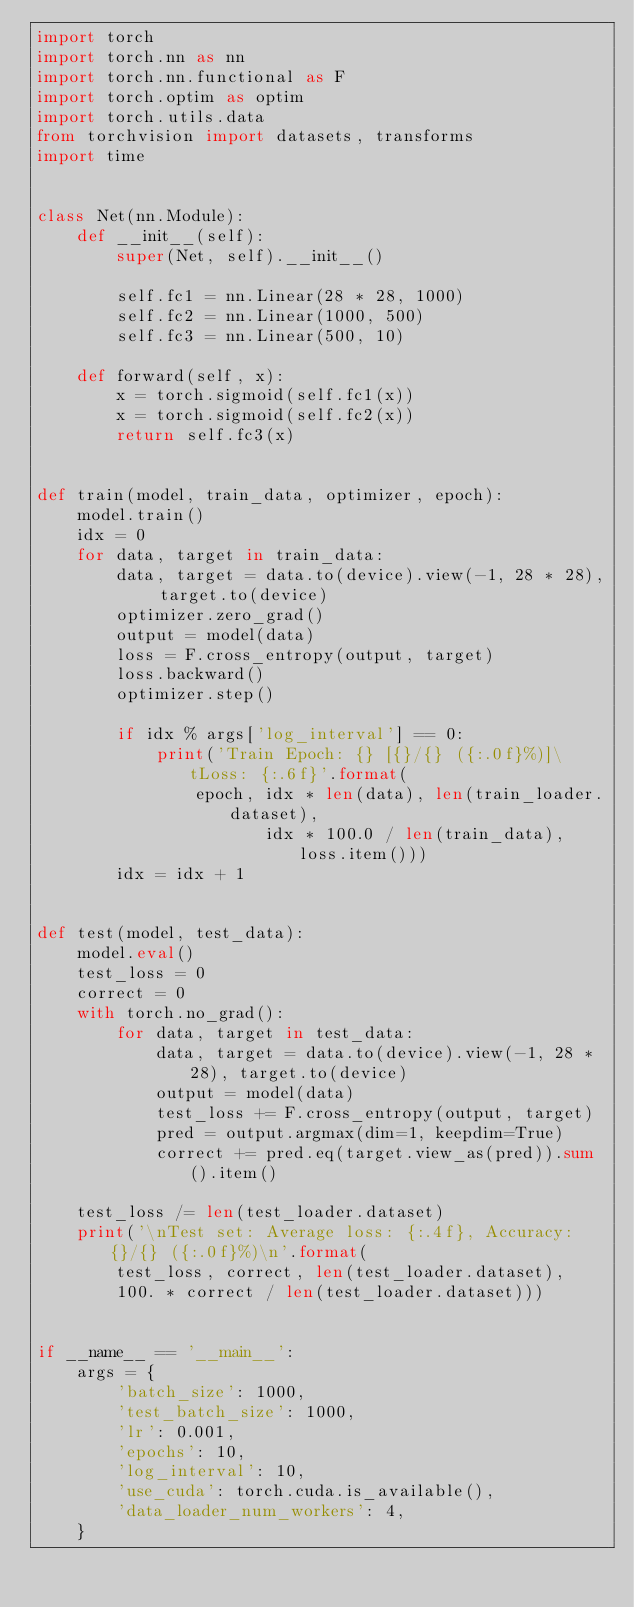Convert code to text. <code><loc_0><loc_0><loc_500><loc_500><_Python_>import torch
import torch.nn as nn
import torch.nn.functional as F
import torch.optim as optim
import torch.utils.data
from torchvision import datasets, transforms
import time


class Net(nn.Module):
    def __init__(self):
        super(Net, self).__init__()

        self.fc1 = nn.Linear(28 * 28, 1000)
        self.fc2 = nn.Linear(1000, 500)
        self.fc3 = nn.Linear(500, 10)

    def forward(self, x):
        x = torch.sigmoid(self.fc1(x))
        x = torch.sigmoid(self.fc2(x))
        return self.fc3(x)


def train(model, train_data, optimizer, epoch):
    model.train()
    idx = 0
    for data, target in train_data:
        data, target = data.to(device).view(-1, 28 * 28), target.to(device)
        optimizer.zero_grad()
        output = model(data)
        loss = F.cross_entropy(output, target)
        loss.backward()
        optimizer.step()

        if idx % args['log_interval'] == 0:
            print('Train Epoch: {} [{}/{} ({:.0f}%)]\tLoss: {:.6f}'.format(
                epoch, idx * len(data), len(train_loader.dataset),
                       idx * 100.0 / len(train_data), loss.item()))
        idx = idx + 1


def test(model, test_data):
    model.eval()
    test_loss = 0
    correct = 0
    with torch.no_grad():
        for data, target in test_data:
            data, target = data.to(device).view(-1, 28 * 28), target.to(device)
            output = model(data)
            test_loss += F.cross_entropy(output, target)
            pred = output.argmax(dim=1, keepdim=True)
            correct += pred.eq(target.view_as(pred)).sum().item()

    test_loss /= len(test_loader.dataset)
    print('\nTest set: Average loss: {:.4f}, Accuracy: {}/{} ({:.0f}%)\n'.format(
        test_loss, correct, len(test_loader.dataset),
        100. * correct / len(test_loader.dataset)))


if __name__ == '__main__':
    args = {
        'batch_size': 1000,
        'test_batch_size': 1000,
        'lr': 0.001,
        'epochs': 10,
        'log_interval': 10,
        'use_cuda': torch.cuda.is_available(),
        'data_loader_num_workers': 4,
    }</code> 